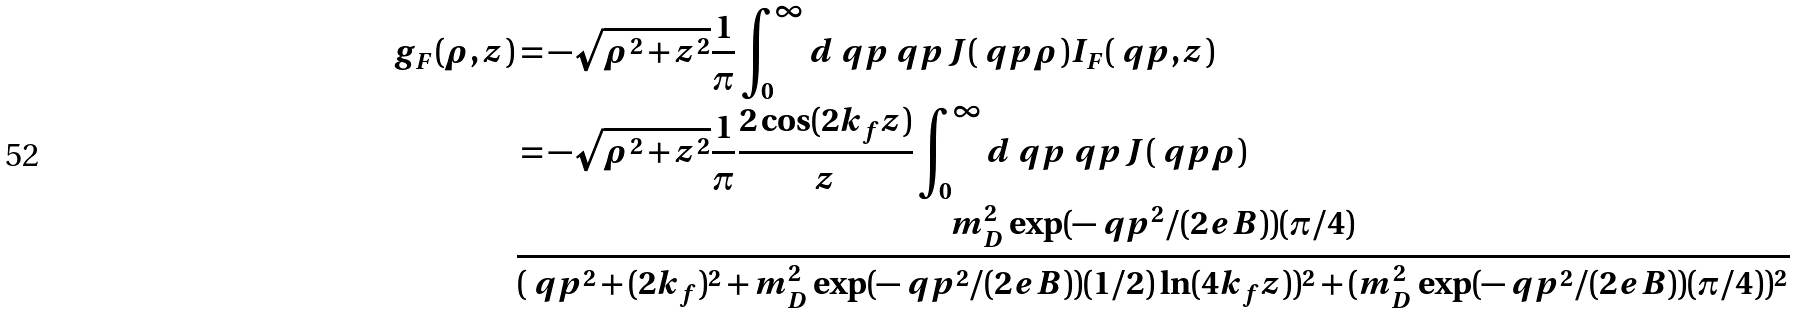Convert formula to latex. <formula><loc_0><loc_0><loc_500><loc_500>g _ { F } ( \rho , z ) & = - \sqrt { \rho ^ { 2 } + z ^ { 2 } } \frac { 1 } { \pi } \int _ { 0 } ^ { \infty } d \ q p \ q p J ( \ q p \rho ) I _ { F } ( \ q p , z ) \\ & = - \sqrt { \rho ^ { 2 } + z ^ { 2 } } \frac { 1 } { \pi } \frac { 2 \cos ( 2 k _ { f } z ) } { z } \int _ { 0 } ^ { \infty } d \ q p \ q p J ( \ q p \rho ) \\ & \frac { m _ { D } ^ { 2 } \exp ( - \ q p ^ { 2 } / ( 2 e B ) ) ( \pi / 4 ) } { ( \ q p ^ { 2 } + ( 2 k _ { f } ) ^ { 2 } + m _ { D } ^ { 2 } \exp ( - \ q p ^ { 2 } / ( 2 e B ) ) ( 1 / 2 ) \ln ( 4 k _ { f } z ) ) ^ { 2 } + ( m _ { D } ^ { 2 } \exp ( - \ q p ^ { 2 } / ( 2 e B ) ) ( \pi / 4 ) ) ^ { 2 } } \\</formula> 